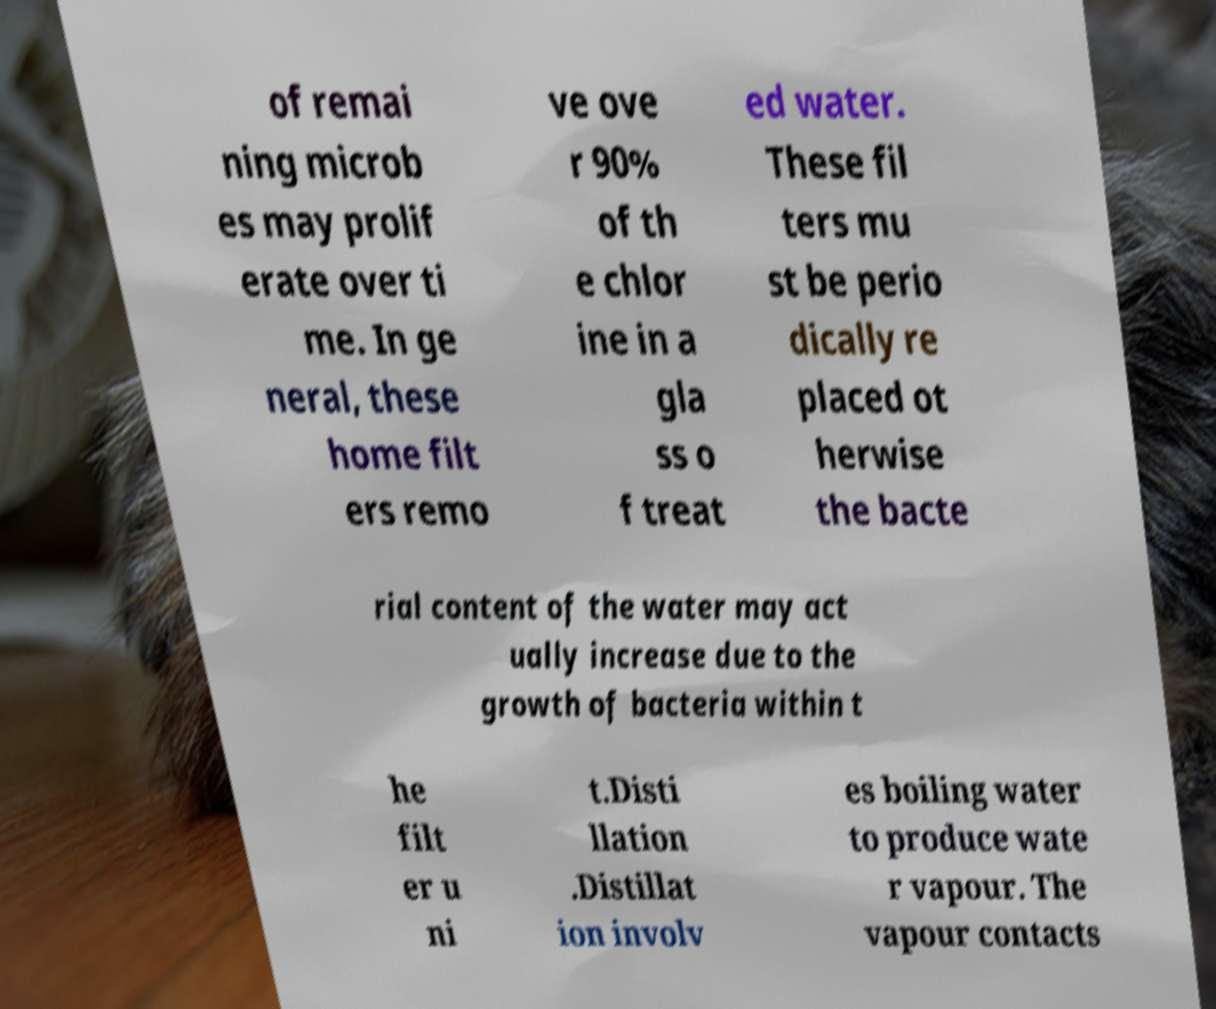Can you accurately transcribe the text from the provided image for me? of remai ning microb es may prolif erate over ti me. In ge neral, these home filt ers remo ve ove r 90% of th e chlor ine in a gla ss o f treat ed water. These fil ters mu st be perio dically re placed ot herwise the bacte rial content of the water may act ually increase due to the growth of bacteria within t he filt er u ni t.Disti llation .Distillat ion involv es boiling water to produce wate r vapour. The vapour contacts 